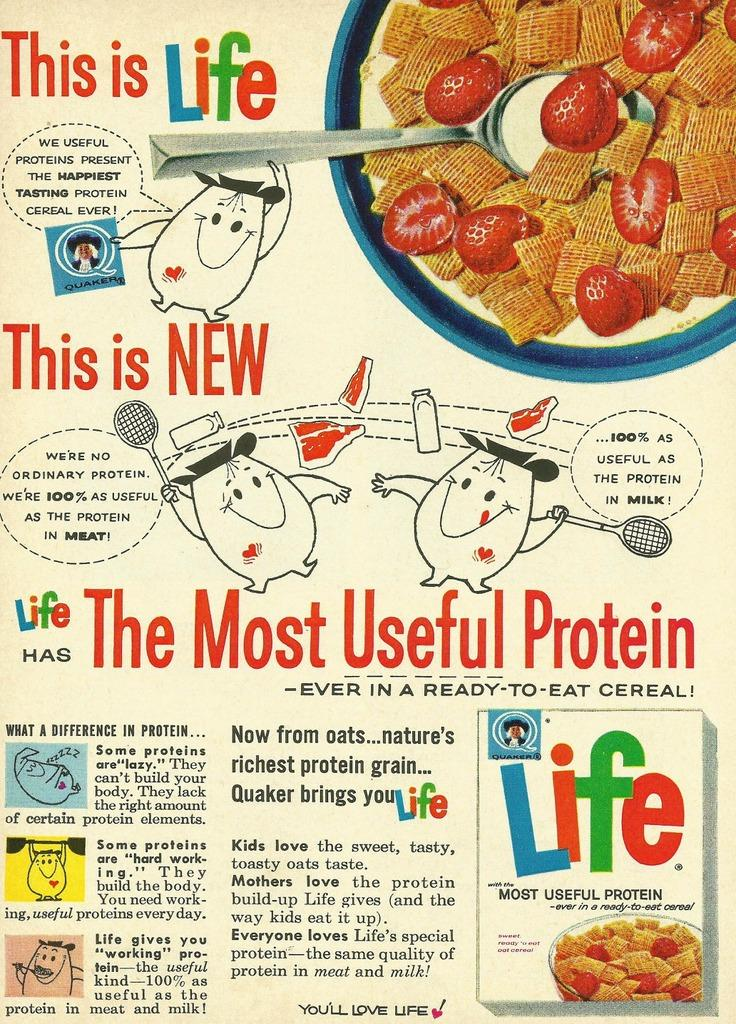What type of visual is the image? The image is a poster. What kind of images can be seen on the poster? There are cartoon images on the poster. What objects are depicted on the poster? There are bottles and a bowl with food items on the poster. What utensil is in the bowl on the poster? There is a spoon in the bowl on the poster. Are there any symbols on the poster? Yes, there are some symbols on the poster. What color crayon is used to draw the station on the poster? There is no crayon or station depicted on the poster; it features cartoon images, bottles, a bowl with food items, a spoon, and some symbols. 